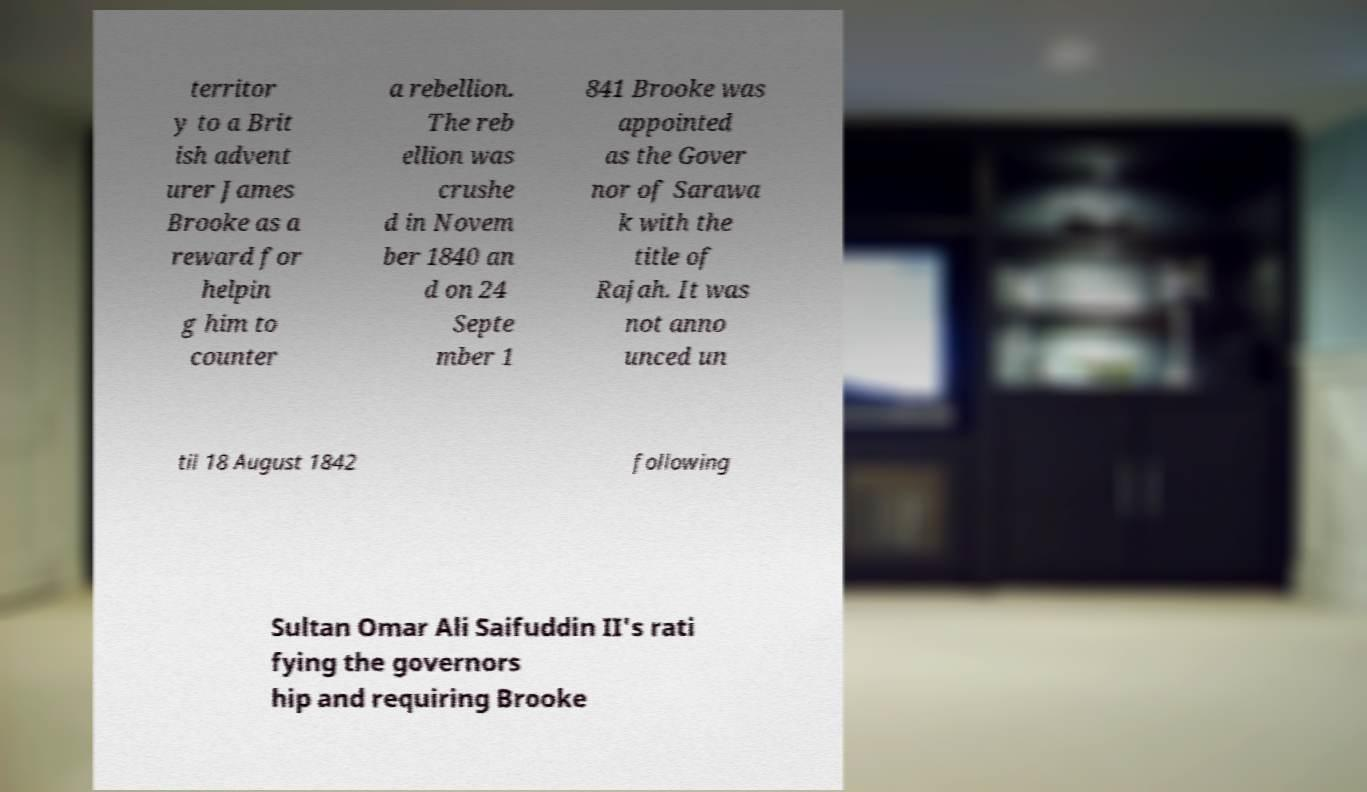Can you accurately transcribe the text from the provided image for me? territor y to a Brit ish advent urer James Brooke as a reward for helpin g him to counter a rebellion. The reb ellion was crushe d in Novem ber 1840 an d on 24 Septe mber 1 841 Brooke was appointed as the Gover nor of Sarawa k with the title of Rajah. It was not anno unced un til 18 August 1842 following Sultan Omar Ali Saifuddin II's rati fying the governors hip and requiring Brooke 